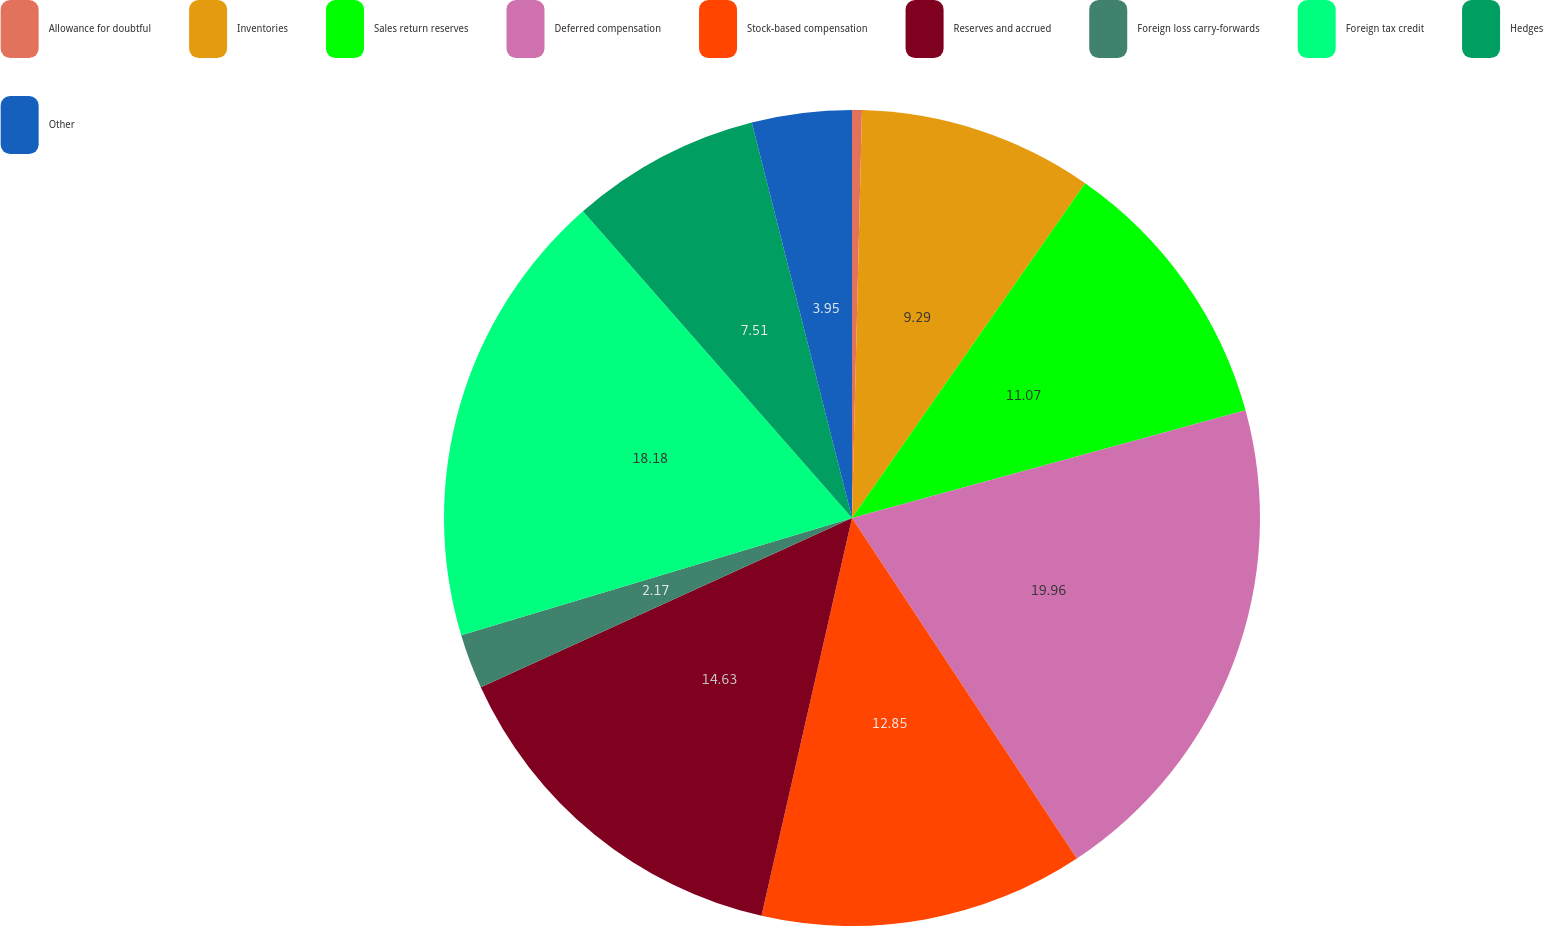Convert chart. <chart><loc_0><loc_0><loc_500><loc_500><pie_chart><fcel>Allowance for doubtful<fcel>Inventories<fcel>Sales return reserves<fcel>Deferred compensation<fcel>Stock-based compensation<fcel>Reserves and accrued<fcel>Foreign loss carry-forwards<fcel>Foreign tax credit<fcel>Hedges<fcel>Other<nl><fcel>0.39%<fcel>9.29%<fcel>11.07%<fcel>19.96%<fcel>12.85%<fcel>14.63%<fcel>2.17%<fcel>18.18%<fcel>7.51%<fcel>3.95%<nl></chart> 